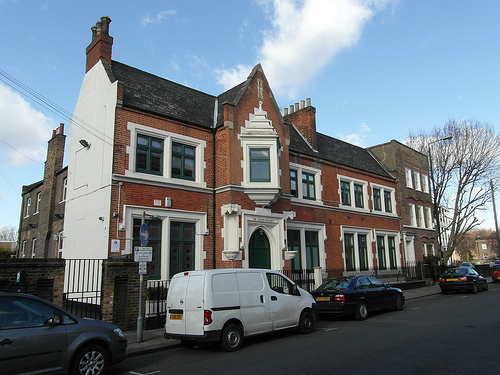<image>
Is the man on the car? No. The man is not positioned on the car. They may be near each other, but the man is not supported by or resting on top of the car. Is the van in the road? Yes. The van is contained within or inside the road, showing a containment relationship. 